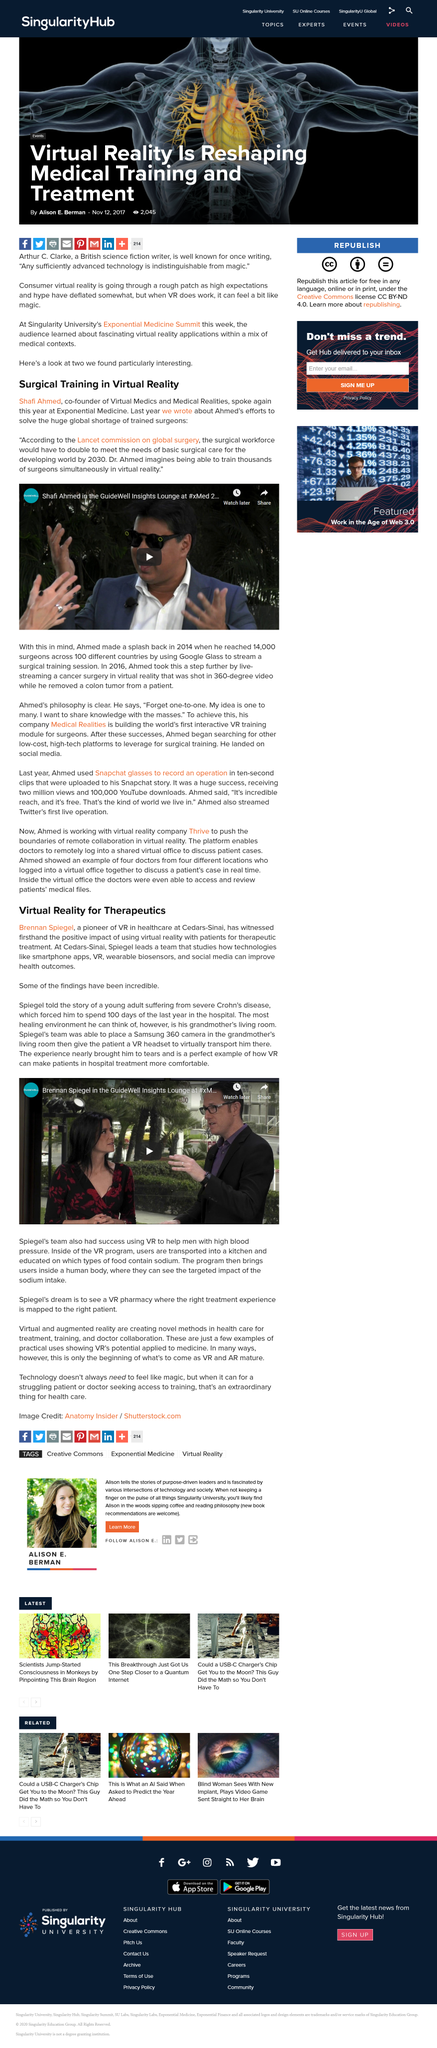Indicate a few pertinent items in this graphic. The purpose of VR technology in healthcare is to provide patients with a therapeutic and immersive experience that can alleviate their emotional distress and improve their overall wellbeing, especially when they are confined to the hospital for an extended period. Shafi Ahmed spoke at Exponential Medicine. The technology used in healthcare virtual reality includes 360 cameras, VR headsets, smartphone apps, wearable biosensors, and social media, which provide a comprehensive and immersive experience for patients and healthcare professionals alike. Brennan Spiegel is a pioneer in the use of VR for therapeutics. It is possible to train thousands of surgeons simultaneously using virtual reality technology. 